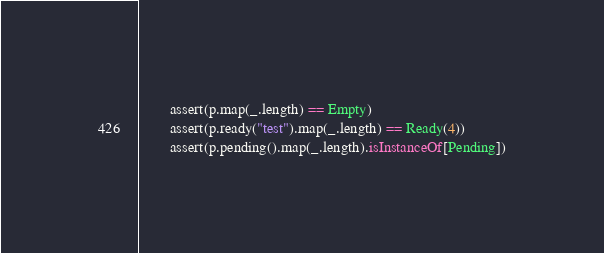<code> <loc_0><loc_0><loc_500><loc_500><_Scala_>        assert(p.map(_.length) == Empty)
        assert(p.ready("test").map(_.length) == Ready(4))
        assert(p.pending().map(_.length).isInstanceOf[Pending])</code> 